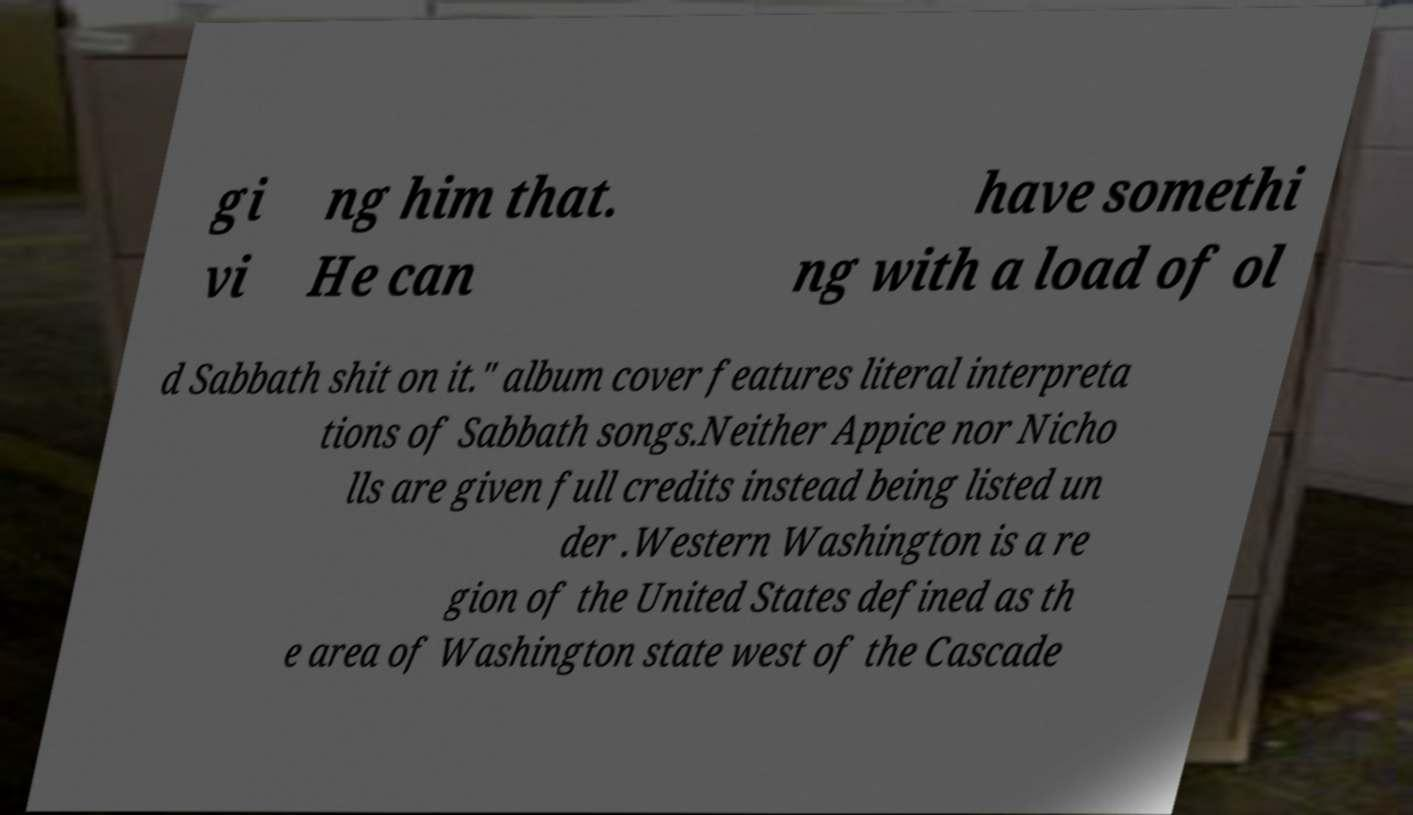Could you assist in decoding the text presented in this image and type it out clearly? gi vi ng him that. He can have somethi ng with a load of ol d Sabbath shit on it." album cover features literal interpreta tions of Sabbath songs.Neither Appice nor Nicho lls are given full credits instead being listed un der .Western Washington is a re gion of the United States defined as th e area of Washington state west of the Cascade 